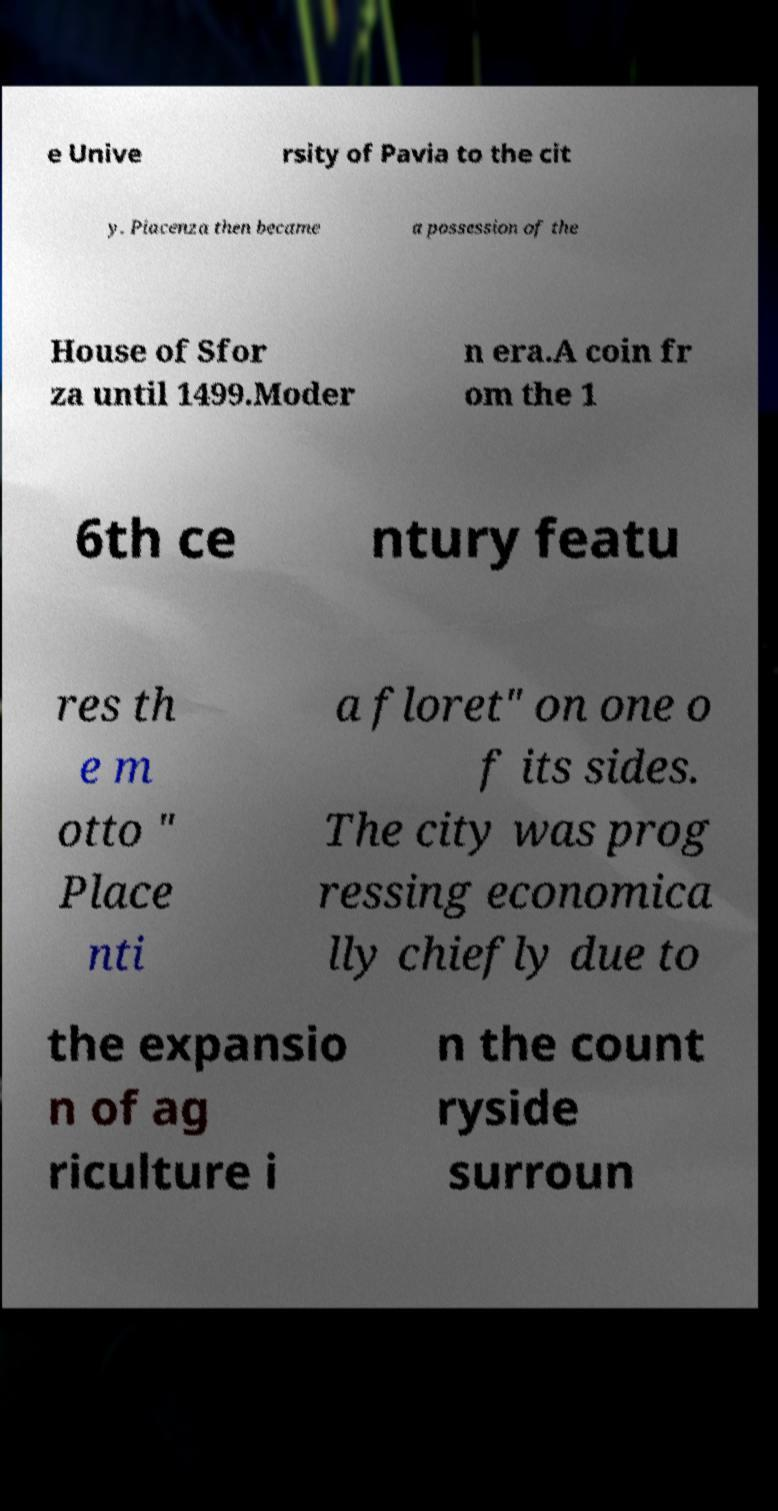Please identify and transcribe the text found in this image. e Unive rsity of Pavia to the cit y. Piacenza then became a possession of the House of Sfor za until 1499.Moder n era.A coin fr om the 1 6th ce ntury featu res th e m otto " Place nti a floret" on one o f its sides. The city was prog ressing economica lly chiefly due to the expansio n of ag riculture i n the count ryside surroun 